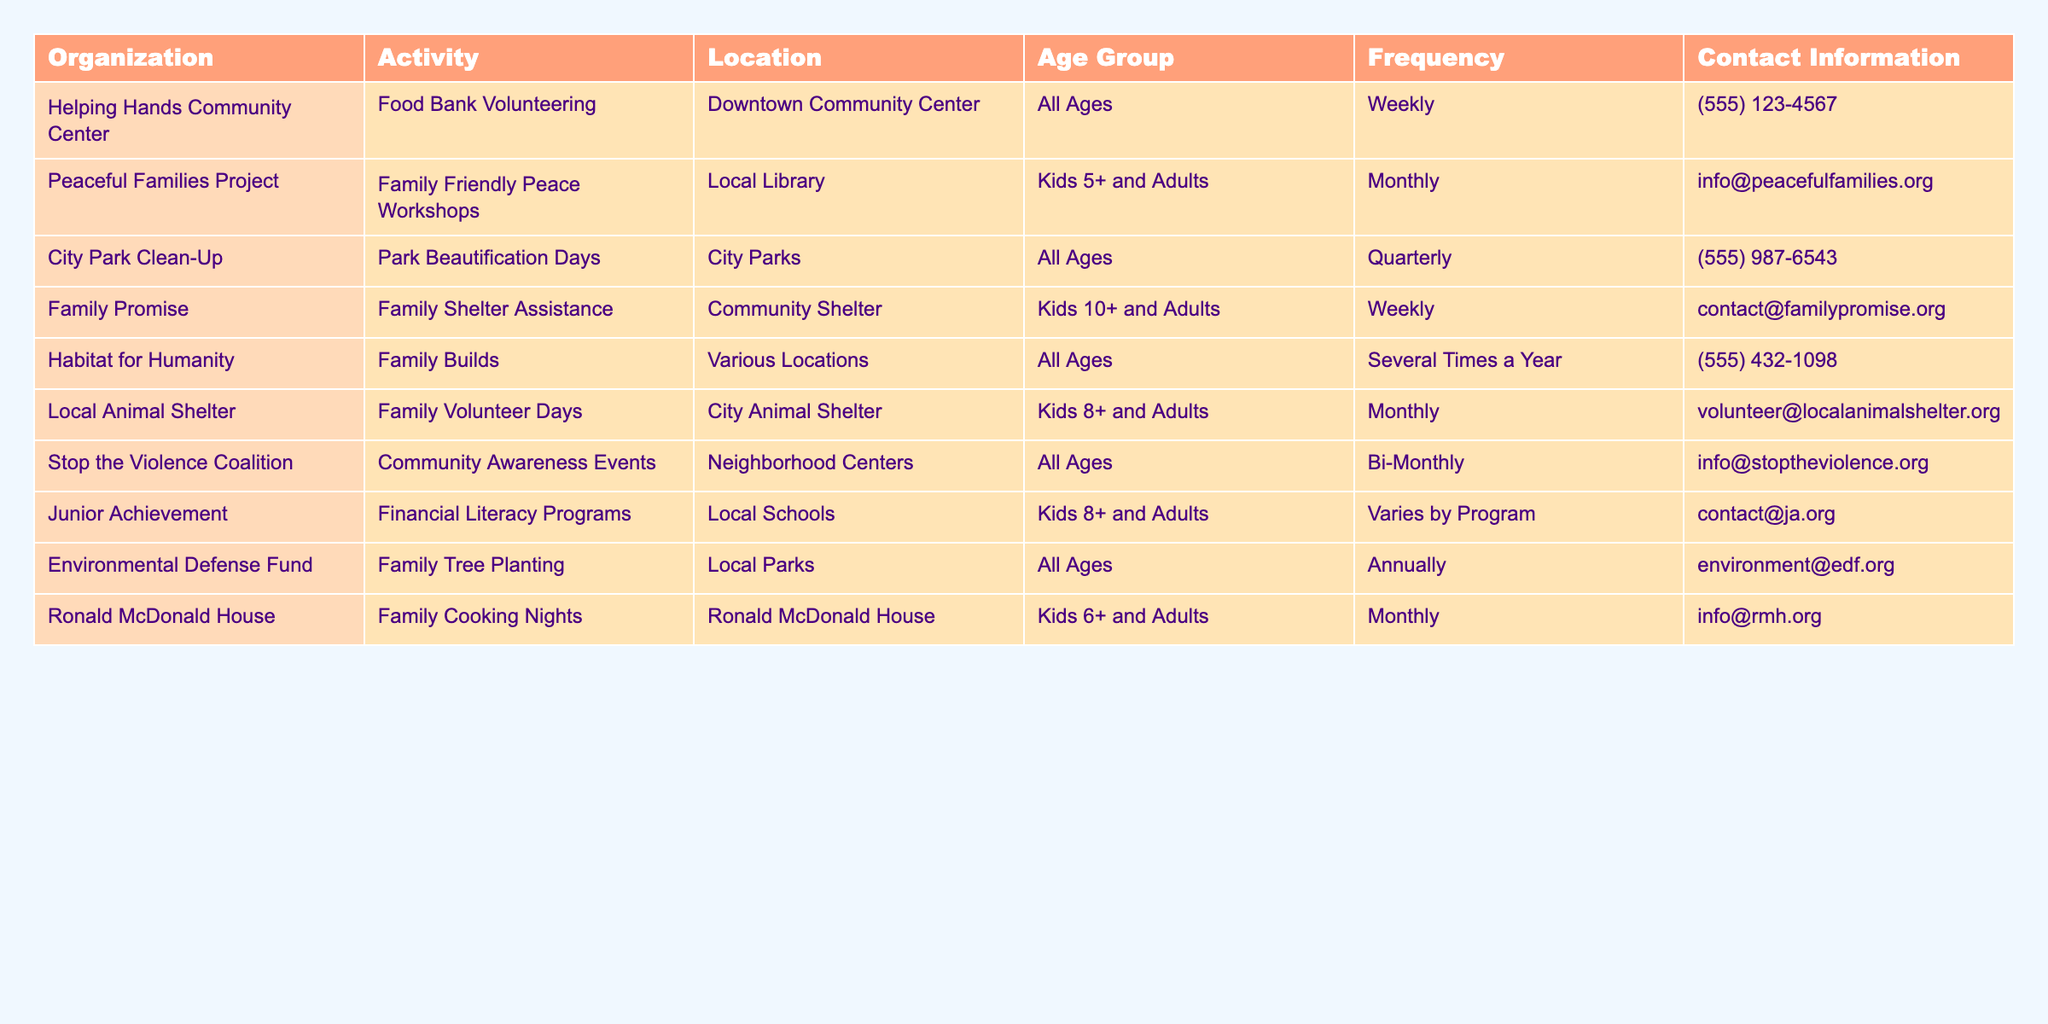What activities can families participate in weekly? The table lists "Family Promise" for shelter assistance and "Helping Hands Community Center" for food bank volunteering, both occurring weekly.
Answer: Family Promise and Helping Hands Community Center Which organizations offer monthly volunteer opportunities for families? The table shows “Peaceful Families Project,” “Local Animal Shelter,” and “Ronald McDonald House” as the organizations that offer monthly volunteering activities.
Answer: Peaceful Families Project, Local Animal Shelter, Ronald McDonald House How many activities listed are suitable for all ages? By reviewing the table, "Helping Hands Community Center," "City Park Clean-Up," "Stop the Violence Coalition," "Environmental Defense Fund," and "Habitat for Humanity" are suitable for all ages, totaling 5 activities.
Answer: 5 Are there more activities for kids aged 6 and up or 8 and up? Counting the activities, there are 4 for kids aged 8 and up ("Local Animal Shelter," "Junior Achievement," "Family Promise," and "Ronald McDonald House") and 2 for kids aged 6 and up ("Ronald McDonald House"), providing a total of 4 for 8+ and 1 for 6+. Therefore, 8 and up has more activities.
Answer: 8 and up What is the frequency of the "City Park Clean-Up" activity? The table indicates that the "City Park Clean-Up" occurs quarterly.
Answer: Quarterly How many organizations offer opportunities at the local parks? The table mentions two organizations: "Environmental Defense Fund" and "City Park Clean-Up" that have activities in local parks.
Answer: 2 Are there any volunteering opportunities related to animal care? Yes, the "Local Animal Shelter" has a family volunteer day specifically related to animal care.
Answer: Yes What types of activities do kids aged 5+ and adults participate in? The only listed activity for kids 5+ and adults is the “Peaceful Families Project” offering workshops.
Answer: Family Friendly Peace Workshops Which organization has a focus on financial literacy? The "Junior Achievement" organization focuses on financial literacy programs for kids 8+ and adults.
Answer: Junior Achievement Compare the frequency of activities offered by the organizations that assist families. "Family Promise" and "Helping Hands Community Center" offer weekly opportunities; "Local Animal Shelter" and "Ronald McDonald House" offer monthly activities; while others occur bi-monthly or quarterly, showing a mix of weekly, monthly, and less frequent opportunities.
Answer: Mixed frequencies of weekly, monthly, etc 